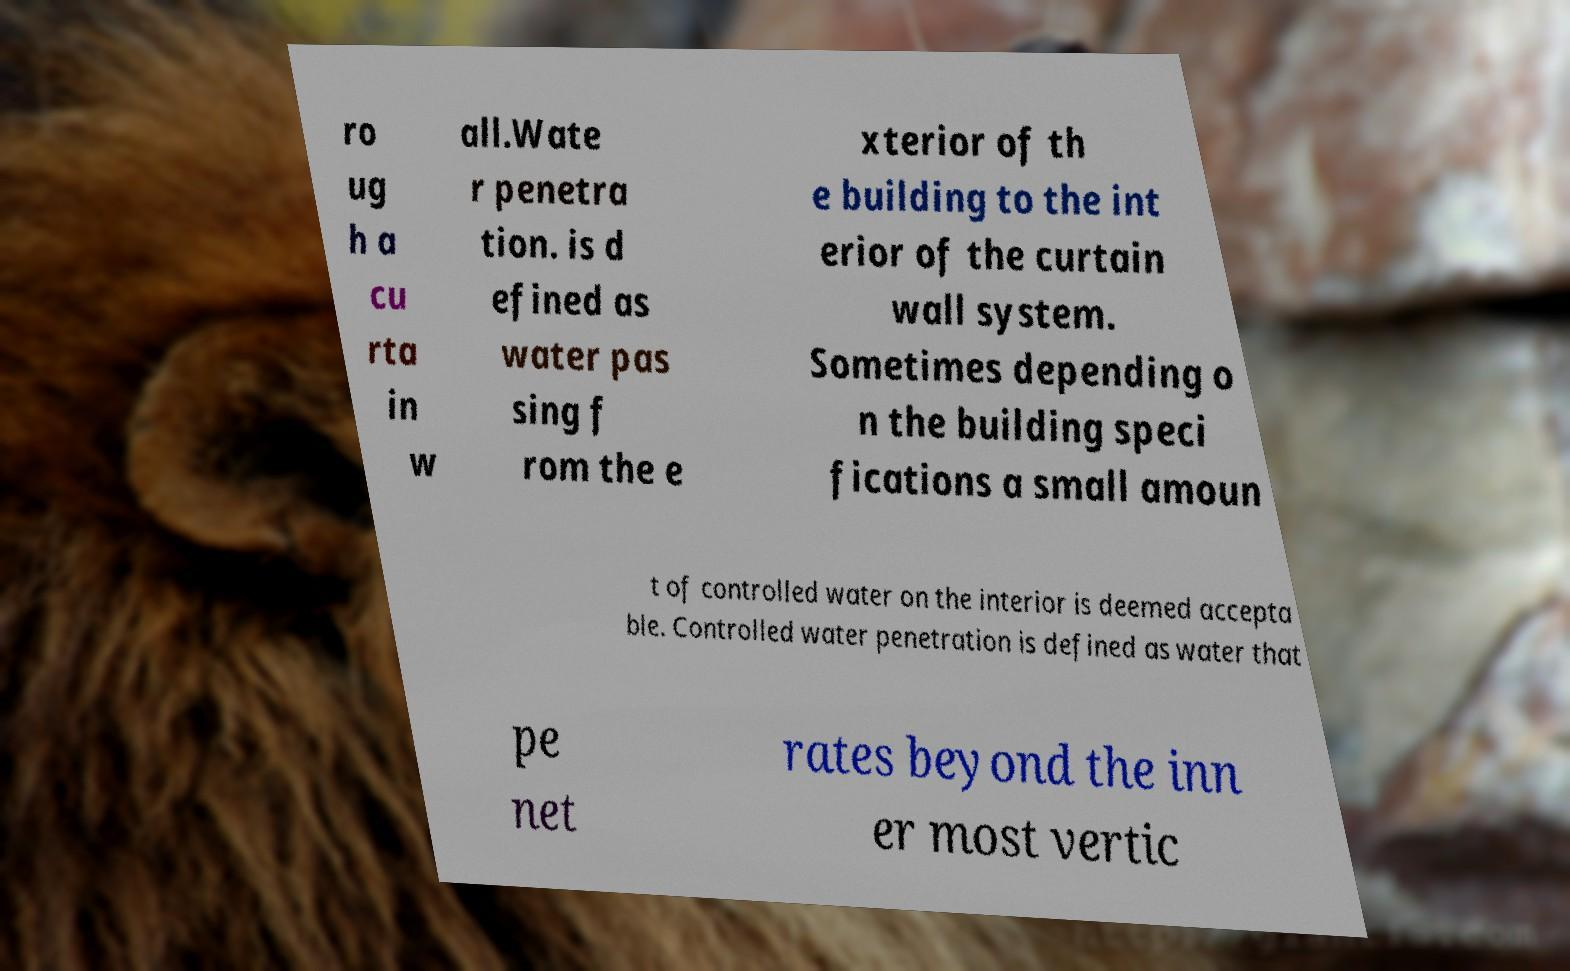I need the written content from this picture converted into text. Can you do that? ro ug h a cu rta in w all.Wate r penetra tion. is d efined as water pas sing f rom the e xterior of th e building to the int erior of the curtain wall system. Sometimes depending o n the building speci fications a small amoun t of controlled water on the interior is deemed accepta ble. Controlled water penetration is defined as water that pe net rates beyond the inn er most vertic 